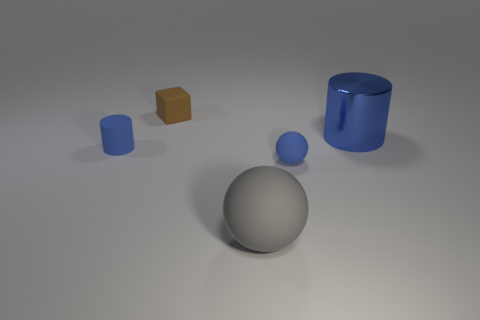What material is the blue object that is both behind the small ball and left of the metal object?
Your answer should be compact. Rubber. Are there more brown objects than big things?
Your response must be concise. No. The large object that is on the left side of the tiny blue object on the right side of the tiny blue matte thing to the left of the brown rubber block is what color?
Make the answer very short. Gray. Are the small object in front of the tiny rubber cylinder and the tiny brown cube made of the same material?
Offer a terse response. Yes. Are there any big metal cylinders that have the same color as the small ball?
Give a very brief answer. Yes. Are there any yellow rubber objects?
Ensure brevity in your answer.  No. Do the cylinder that is in front of the metallic object and the shiny thing have the same size?
Your response must be concise. No. Are there fewer small cubes than tiny green matte objects?
Offer a terse response. No. There is a tiny rubber thing on the right side of the big object in front of the large cylinder that is behind the blue rubber cylinder; what is its shape?
Your answer should be compact. Sphere. Are there any blue objects made of the same material as the large gray thing?
Your answer should be very brief. Yes. 